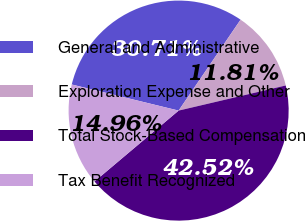<chart> <loc_0><loc_0><loc_500><loc_500><pie_chart><fcel>General and Administrative<fcel>Exploration Expense and Other<fcel>Total Stock-Based Compensation<fcel>Tax Benefit Recognized<nl><fcel>30.71%<fcel>11.81%<fcel>42.52%<fcel>14.96%<nl></chart> 